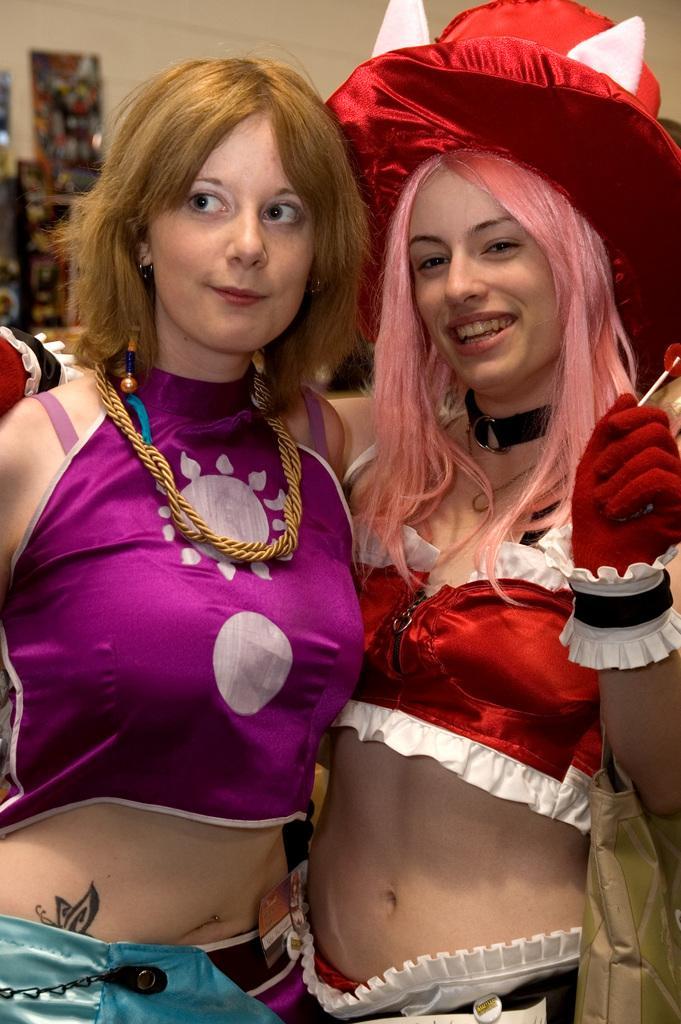Please provide a concise description of this image. In this image, we can see people wearing costumes and one of them is holding an object and wearing a bag. In the background, there is a wall and we can see some boards. 